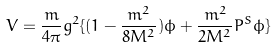Convert formula to latex. <formula><loc_0><loc_0><loc_500><loc_500>V = \frac { m } { 4 \pi } g ^ { 2 } \{ ( 1 - \frac { m ^ { 2 } } { 8 M ^ { 2 } } ) \phi + \frac { m ^ { 2 } } { 2 M ^ { 2 } } P ^ { S } \phi \}</formula> 